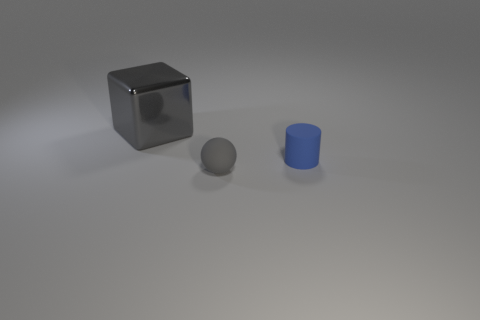Add 3 large red matte objects. How many objects exist? 6 Subtract all blocks. How many objects are left? 2 Add 3 small metal cylinders. How many small metal cylinders exist? 3 Subtract 0 red cylinders. How many objects are left? 3 Subtract all large gray objects. Subtract all tiny matte spheres. How many objects are left? 1 Add 3 big things. How many big things are left? 4 